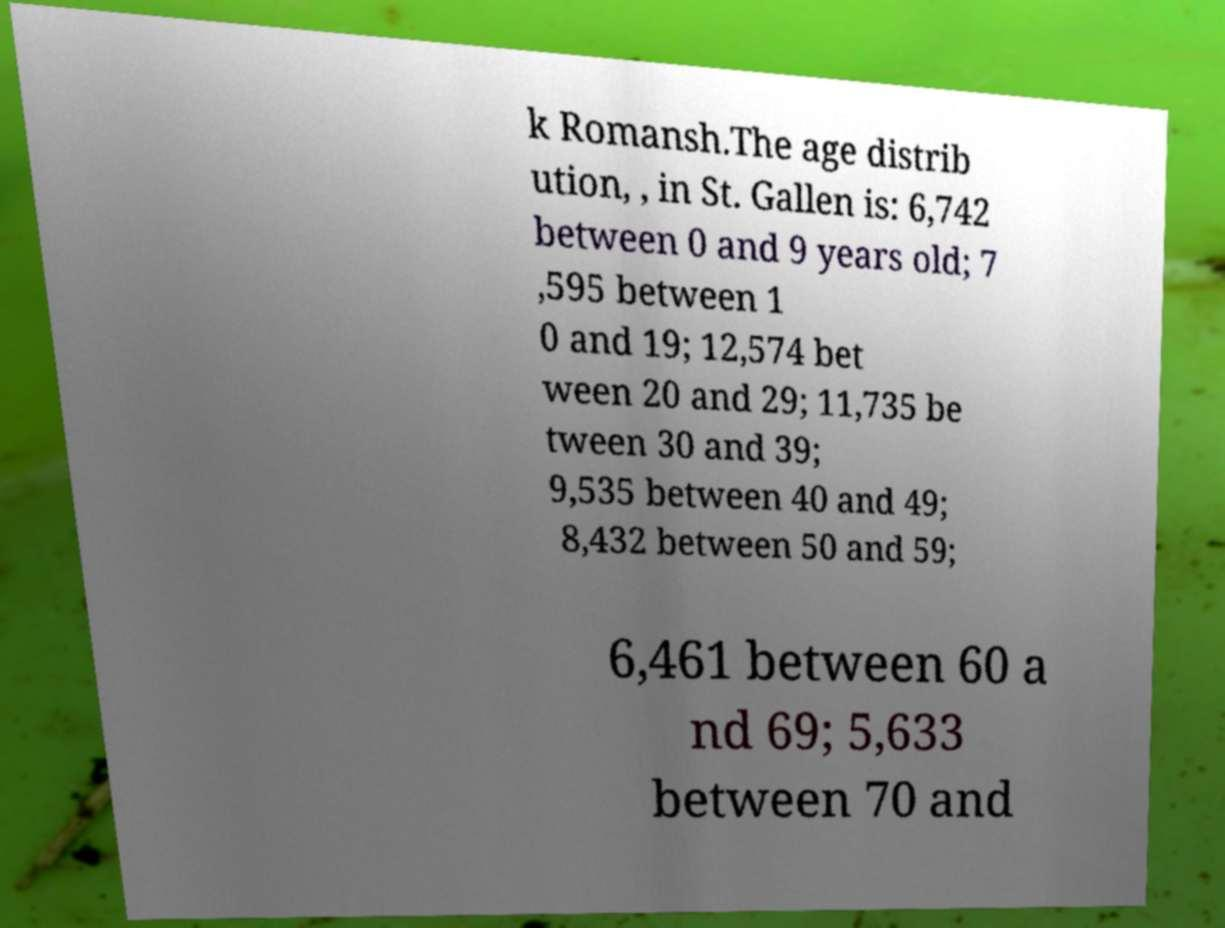Could you assist in decoding the text presented in this image and type it out clearly? k Romansh.The age distrib ution, , in St. Gallen is: 6,742 between 0 and 9 years old; 7 ,595 between 1 0 and 19; 12,574 bet ween 20 and 29; 11,735 be tween 30 and 39; 9,535 between 40 and 49; 8,432 between 50 and 59; 6,461 between 60 a nd 69; 5,633 between 70 and 